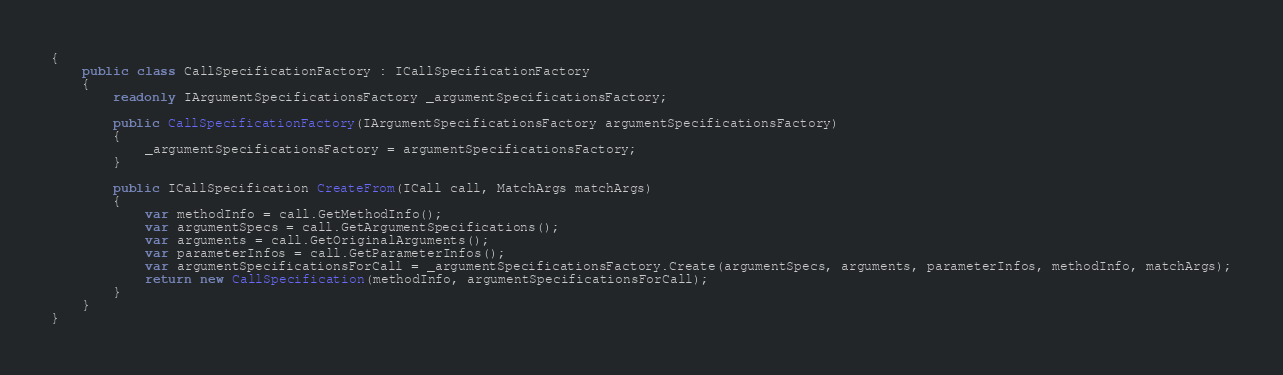<code> <loc_0><loc_0><loc_500><loc_500><_C#_>{
    public class CallSpecificationFactory : ICallSpecificationFactory
    {
        readonly IArgumentSpecificationsFactory _argumentSpecificationsFactory;

        public CallSpecificationFactory(IArgumentSpecificationsFactory argumentSpecificationsFactory)
        {
            _argumentSpecificationsFactory = argumentSpecificationsFactory;
        }

        public ICallSpecification CreateFrom(ICall call, MatchArgs matchArgs)
        {
            var methodInfo = call.GetMethodInfo();
            var argumentSpecs = call.GetArgumentSpecifications();
            var arguments = call.GetOriginalArguments();
            var parameterInfos = call.GetParameterInfos();
            var argumentSpecificationsForCall = _argumentSpecificationsFactory.Create(argumentSpecs, arguments, parameterInfos, methodInfo, matchArgs);
            return new CallSpecification(methodInfo, argumentSpecificationsForCall);
        }
    }
}
</code> 